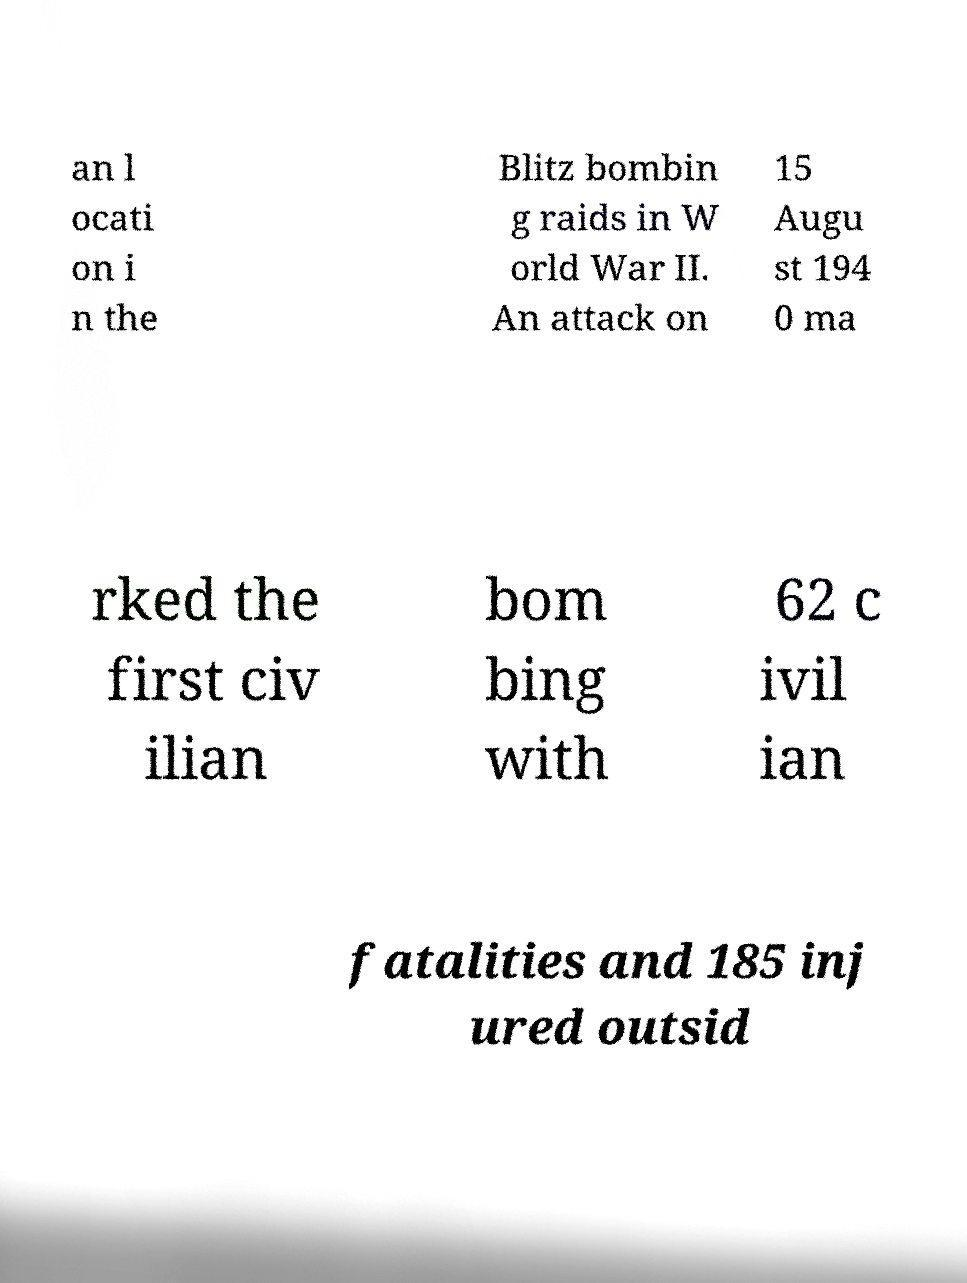For documentation purposes, I need the text within this image transcribed. Could you provide that? an l ocati on i n the Blitz bombin g raids in W orld War II. An attack on 15 Augu st 194 0 ma rked the first civ ilian bom bing with 62 c ivil ian fatalities and 185 inj ured outsid 